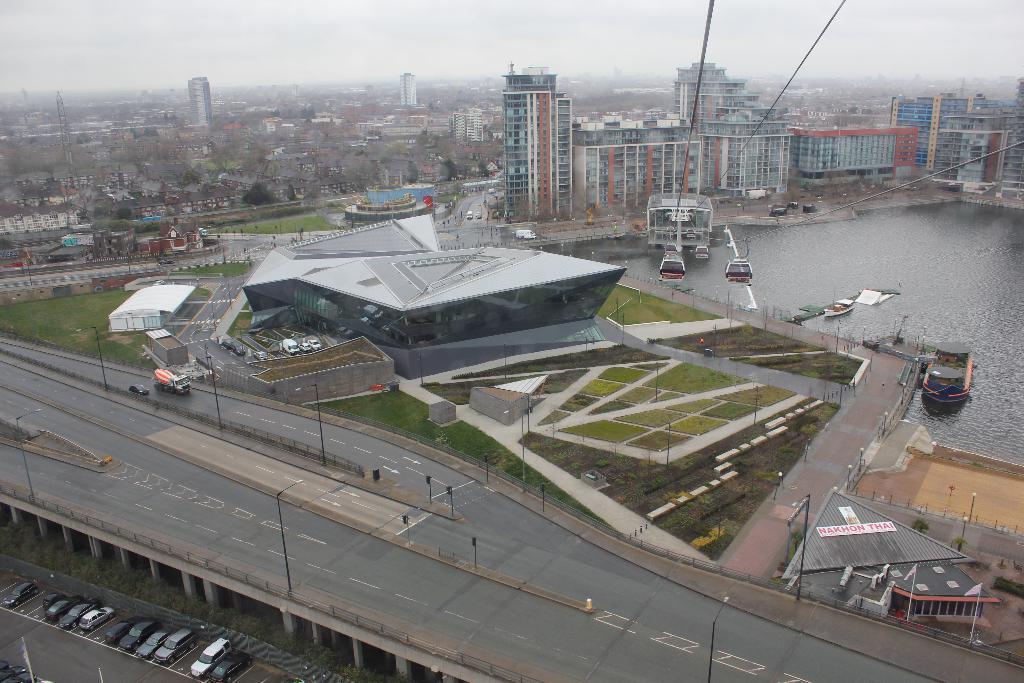Could you give a brief overview of what you see in this image? In this image I can see the road. To the side few the road there are many poles I can see few vehicles on the road. To the side there is a railing and I can also see the building. To the back of the building I can see the water and few boats on it. To the left I can see few more vehicles on the road. In the back there are many buildings, trees and the sky. 